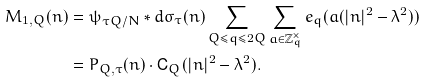Convert formula to latex. <formula><loc_0><loc_0><loc_500><loc_500>M _ { 1 , Q } ( n ) & = \psi _ { \tau Q / N } \ast d \sigma _ { \tau } ( n ) \sum _ { Q \leq q \leq 2 Q } \sum _ { a \in \mathbb { Z } ^ { \times } _ { q } } e _ { q } ( a ( | n | ^ { 2 } - \lambda ^ { 2 } ) ) \\ & = P _ { Q , \tau } ( n ) \cdot \mathsf C _ { Q } ( | n | ^ { 2 } - \lambda ^ { 2 } ) .</formula> 